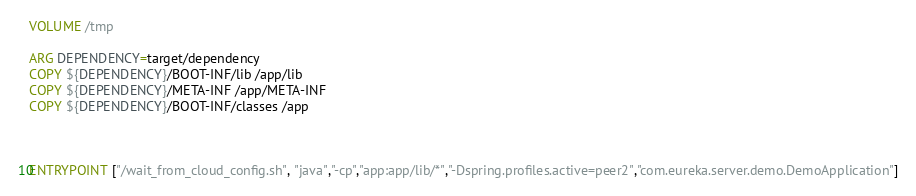<code> <loc_0><loc_0><loc_500><loc_500><_Dockerfile_>VOLUME /tmp

ARG DEPENDENCY=target/dependency
COPY ${DEPENDENCY}/BOOT-INF/lib /app/lib
COPY ${DEPENDENCY}/META-INF /app/META-INF
COPY ${DEPENDENCY}/BOOT-INF/classes /app



ENTRYPOINT ["/wait_from_cloud_config.sh", "java","-cp","app:app/lib/*","-Dspring.profiles.active=peer2","com.eureka.server.demo.DemoApplication"]


</code> 